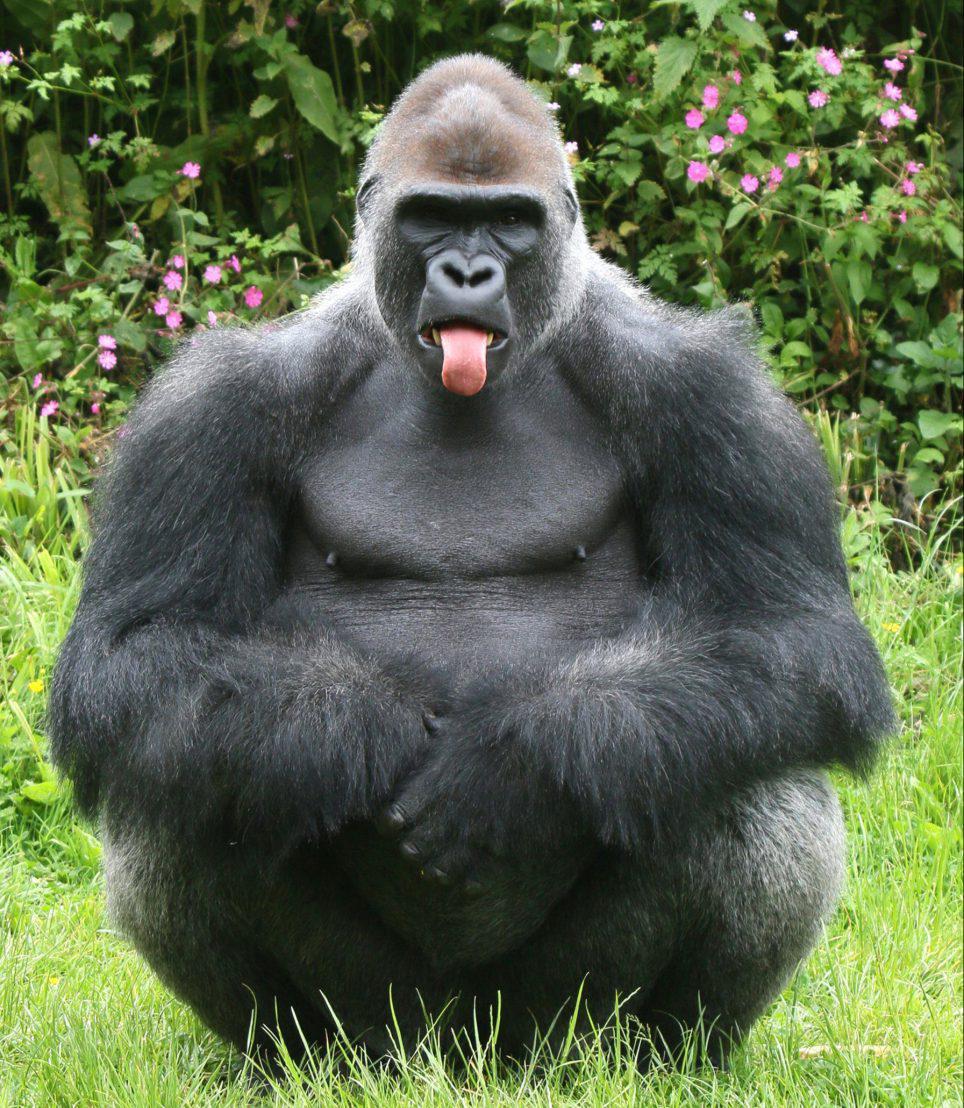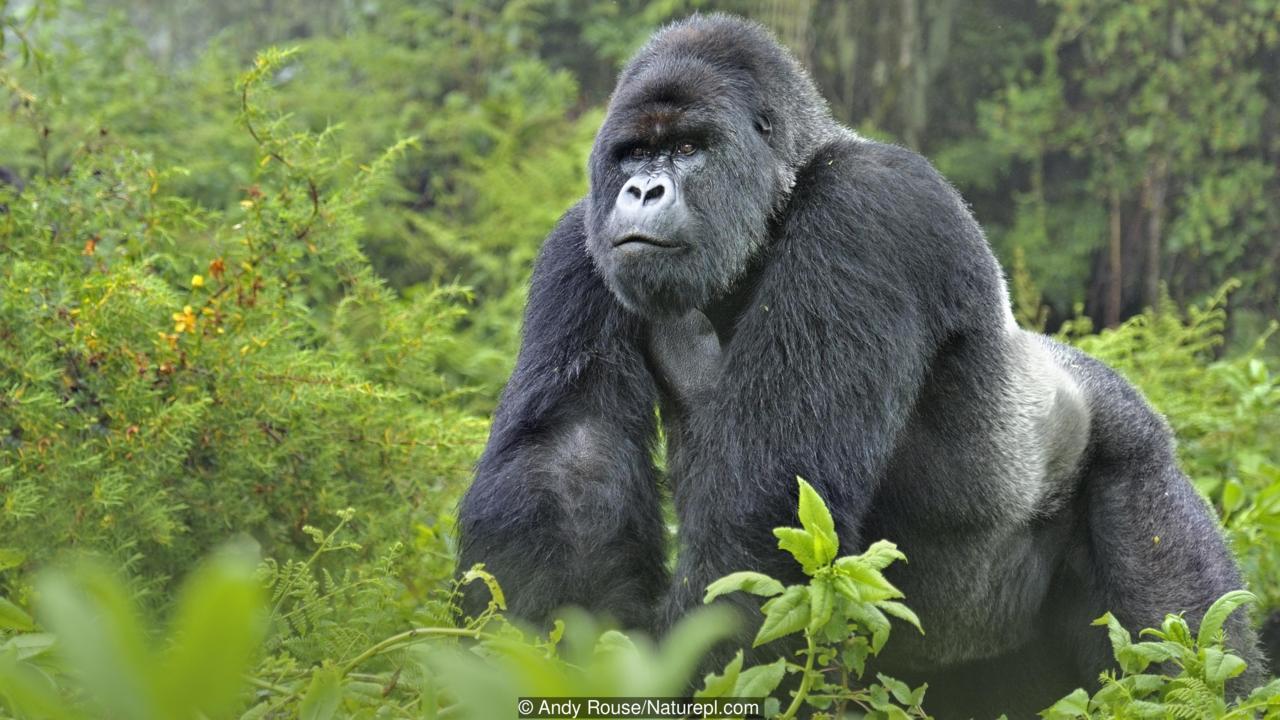The first image is the image on the left, the second image is the image on the right. Given the left and right images, does the statement "There are monkeys on rocks in one of the images" hold true? Answer yes or no. No. The first image is the image on the left, the second image is the image on the right. Given the left and right images, does the statement "The image on the right shows exactly one adult gorilla." hold true? Answer yes or no. Yes. 